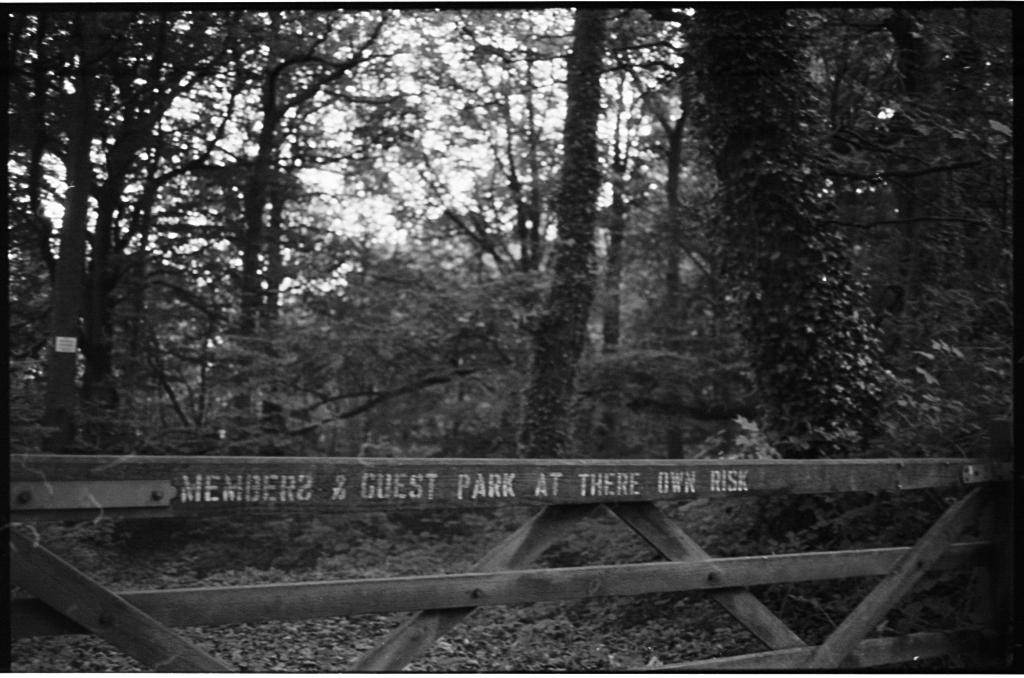What type of material is the fencing in the image made of? The wooden fencing in the image is made of wood. What can be seen in the background of the image? There are trees in the background of the image. What type of sugar is used to sweeten the trees in the image? There is no sugar or sweetening involved in the image; it features a wooden fencing and trees in the background. What shape is the credit card held by the person in the image? There is no person or credit card present in the image. 